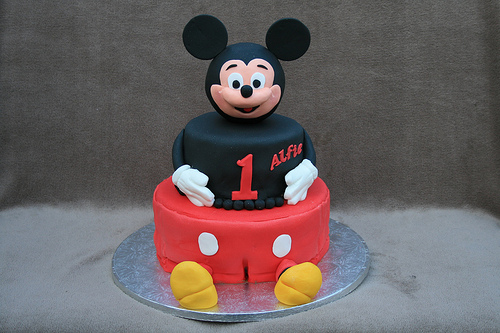<image>
Is there a cake on the wall? No. The cake is not positioned on the wall. They may be near each other, but the cake is not supported by or resting on top of the wall. 